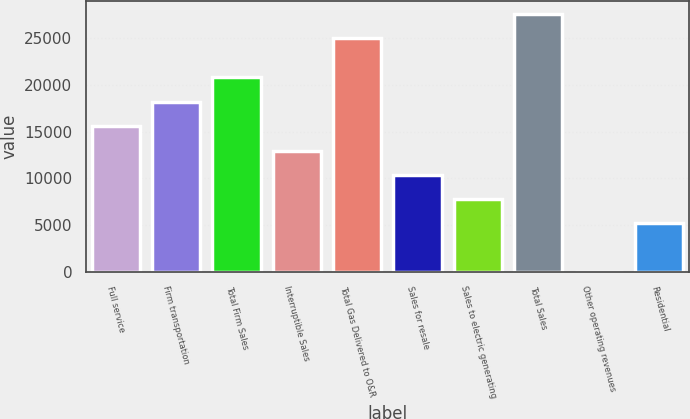Convert chart. <chart><loc_0><loc_0><loc_500><loc_500><bar_chart><fcel>Full service<fcel>Firm transportation<fcel>Total Firm Sales<fcel>Interruptible Sales<fcel>Total Gas Delivered to O&R<fcel>Sales for resale<fcel>Sales to electric generating<fcel>Total Sales<fcel>Other operating revenues<fcel>Residential<nl><fcel>15539.2<fcel>18127.4<fcel>20870<fcel>12951<fcel>24988<fcel>10362.8<fcel>7774.6<fcel>27576.2<fcel>10<fcel>5186.4<nl></chart> 